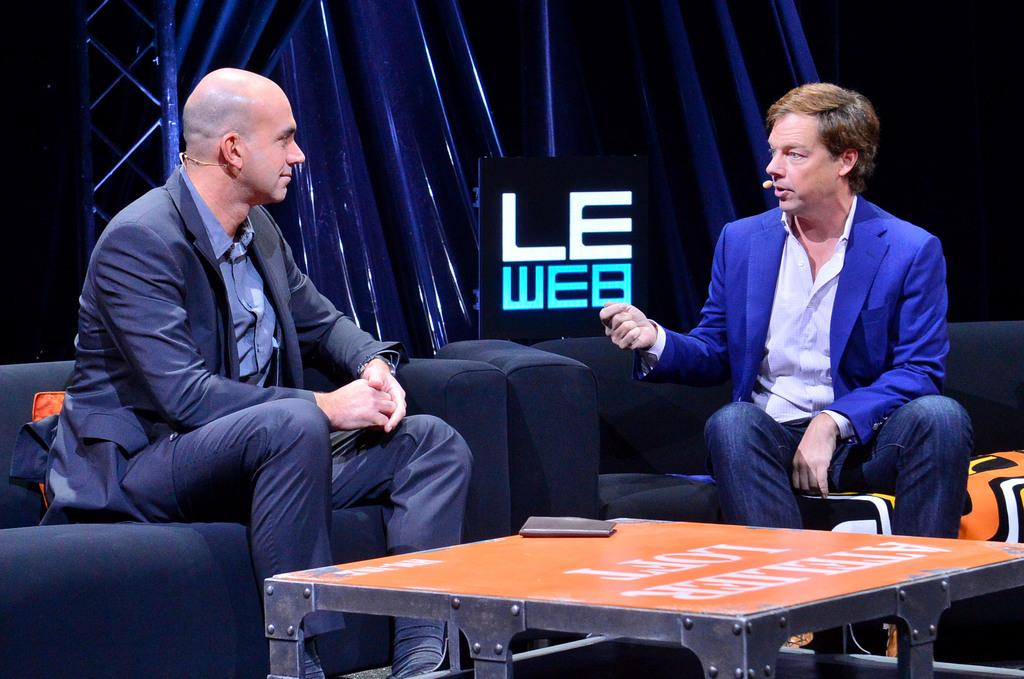How many people are in the image? There are two people in the image. What are the two people doing in the image? The two people are sitting on a sofa and having a conversation. What type of winter clothing are the dogs wearing in the image? There are no dogs present in the image, and therefore no winter clothing for them to wear. 